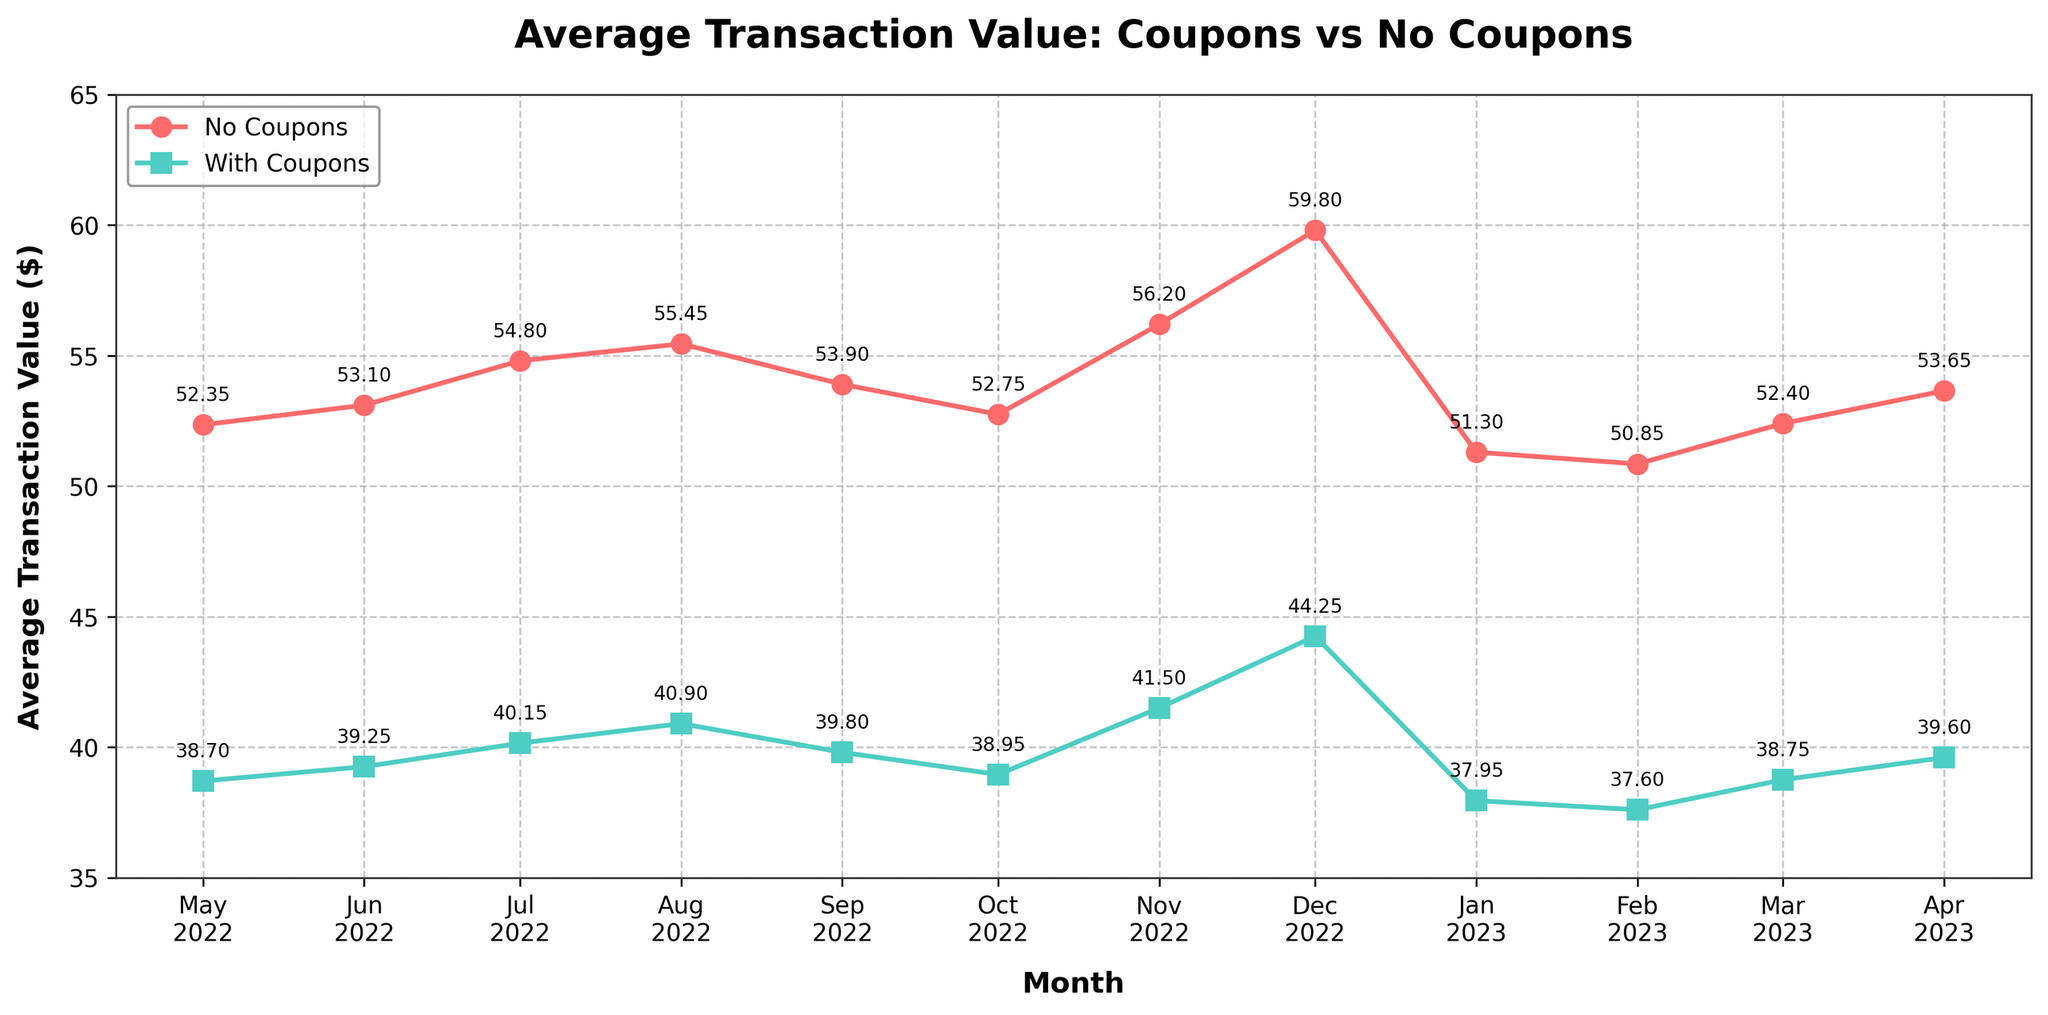What's the difference in average transaction value between with and without coupons in Dec 2022? In Dec 2022, the average transaction value with coupons is $44.25 and without coupons is $59.80. The difference is $59.80 - $44.25.
Answer: $15.55 In which month is the average transaction value with coupons the lowest? By looking at the trend for each month, the data point for Feb 2023 is the lowest at $37.60.
Answer: Feb 2023 Is there any month where the average transaction value with coupons is higher than without coupons? For each month shown, the average transaction value without coupons is consistently higher than with coupons.
Answer: No By how much did the average transaction value with coupons increase from Jul 2022 to Dec 2022? In Jul 2022, the average transaction value with coupons was $40.15 and in Dec 2022 it was $44.25. The increase is $44.25 - $40.15.
Answer: $4.10 Between which two consecutive months was the largest decrease observed in the average transaction value without coupons? By visually examining the line for average transaction value without coupons, the largest decrease happens between Dec 2022 ($59.80) and Jan 2023 ($51.30), a difference of $8.50.
Answer: Dec 2022 to Jan 2023 